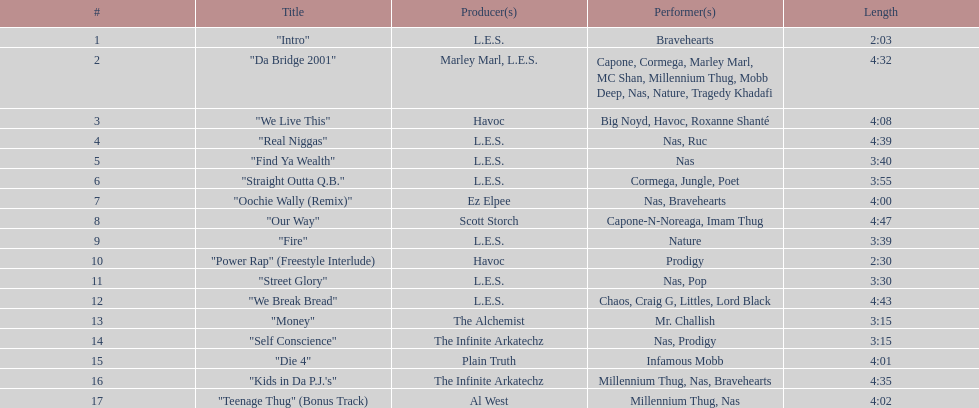What song was performed before "fire"? "Our Way". 